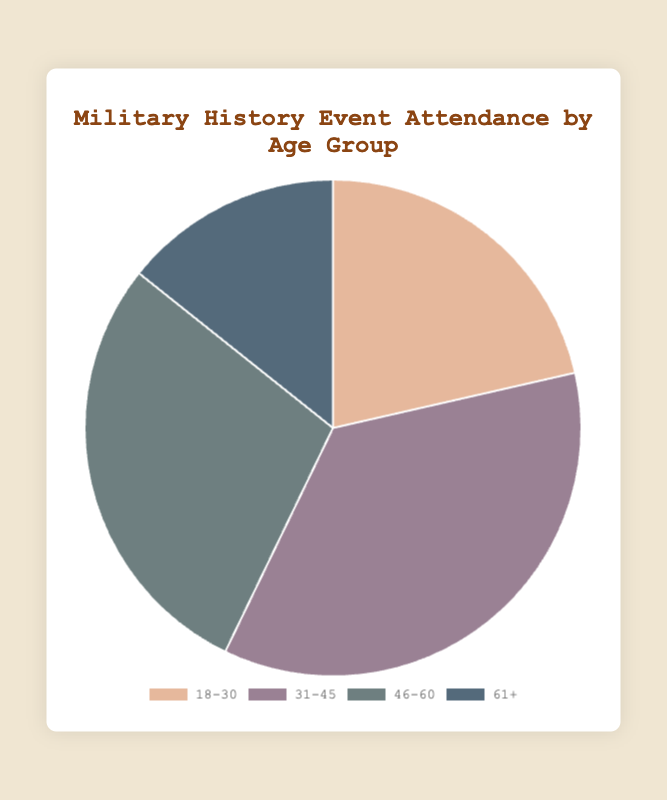What is the age group with the highest number of attendees? To determine the age group with the highest number of attendees, look at the segment of the pie chart that represents the largest portion. The 31-45 age group has the highest attendance count of 75.
Answer: 31-45 Which age group has the smallest number of attendees? By observing the pie chart, identify the smallest segment. The 61+ age group has the smallest attendance count of 30.
Answer: 61+ What is the total number of attendees at the events? Add the attendance counts of all age groups: 45 (18-30) + 75 (31-45) + 60 (46-60) + 30 (61+) = 210 attendees.
Answer: 210 Compare the attendance count of the 18-30 age group to the 61+ age group. Which is higher and by how much? The 18-30 age group has 45 attendees, whereas the 61+ age group has 30 attendees. 45 - 30 = 15 more attendees in the 18-30 age group.
Answer: 18-30 by 15 What is the percentage of attendees in the 46-60 age group? Calculate the percentage by dividing the 46-60 attendance count by the total number of attendees and then multiplying by 100: (60 / 210) * 100 = ~28.57%.
Answer: 28.57% What do the colors represent in the pie chart? The colors are used to differentiate between the different age groups attending the events.
Answer: Different age groups Is the attendance higher in the 18-30 age group or the 46-60 age group? The 46-60 age group has 60 attendees while the 18-30 age group has 45 attendees. Therefore, the 46-60 age group has higher attendance.
Answer: 46-60 Which two age groups have a combined attendance count of over 100? Add up attendance counts of different combinations and check if they are over 100: 18-30 (45) + 31-45 (75) = 120; 31-45 (75) + 46-60 (60) = 135. Both combinations exceed 100 attendees.
Answer: 18-30 and 31-45, 31-45 and 46-60 What is the average number of attendees across all the age groups? To find the average, sum all attendance counts and divide by the number of age groups: (45 + 75 + 60 + 30) / 4 = 52.5 attendees.
Answer: 52.5 How many more attendees are in the 31-45 age group compared to the 61+ age group? Subtract the attendance count of the 61+ age group from the 31-45 age group: 75 - 30 = 45 more attendees.
Answer: 45 